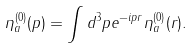Convert formula to latex. <formula><loc_0><loc_0><loc_500><loc_500>\eta ^ { ( 0 ) } _ { a } ( p ) = \int d ^ { 3 } p e ^ { - i p r } \eta ^ { ( 0 ) } _ { a } ( r ) .</formula> 